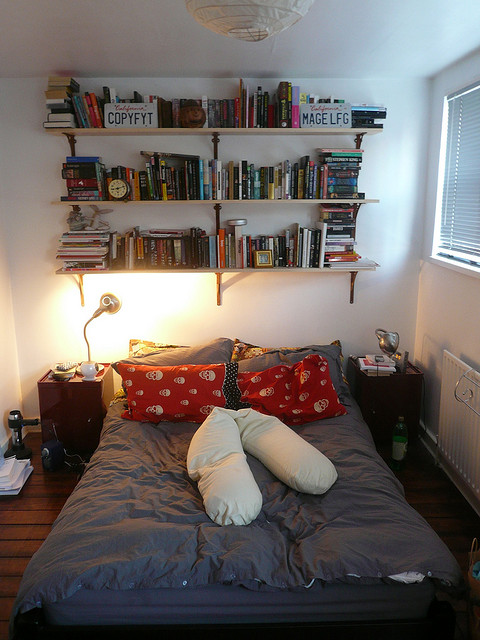How might one feel about spending time reading in this room? One might feel incredibly cozy and comfortable spending time reading in this charmingly dimly lit bedroom. The inviting bed, adorned with vibrant red pillows and a uniquely shaped long white pillow, provides an ideal spot for settling in with a good book. The bookshelf, brimming with a diverse selection of books, stands as a testament to the room's purpose as a personal reading haven. The room's small size, combined with its subtle, neutral color palette, crafts an intimate and tranquil atmosphere, perfect for escaping into the world of literature and finding solace from everyday distractions. 